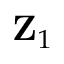<formula> <loc_0><loc_0><loc_500><loc_500>Z _ { 1 }</formula> 